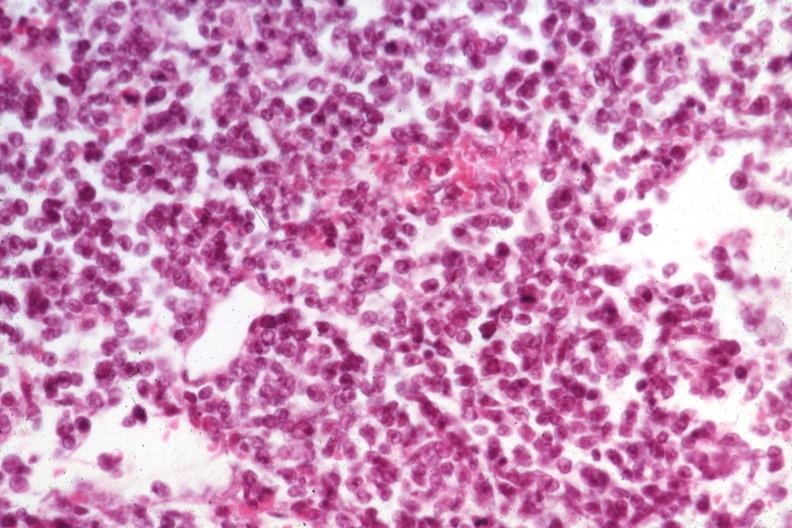s lymph node present?
Answer the question using a single word or phrase. Yes 